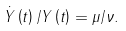Convert formula to latex. <formula><loc_0><loc_0><loc_500><loc_500>\dot { Y } \left ( t \right ) / Y \left ( t \right ) = \mu / \nu .</formula> 